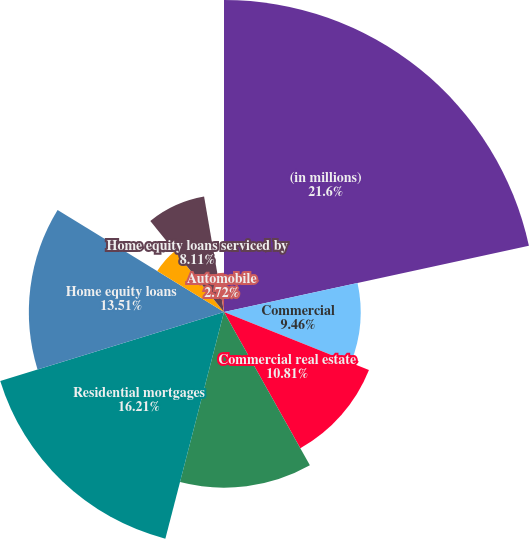<chart> <loc_0><loc_0><loc_500><loc_500><pie_chart><fcel>(in millions)<fcel>Commercial<fcel>Commercial real estate<fcel>Total commercial<fcel>Residential mortgages<fcel>Home equity loans<fcel>Home equity lines of credit<fcel>Home equity loans serviced by<fcel>Automobile<nl><fcel>21.6%<fcel>9.46%<fcel>10.81%<fcel>12.16%<fcel>16.21%<fcel>13.51%<fcel>5.42%<fcel>8.11%<fcel>2.72%<nl></chart> 